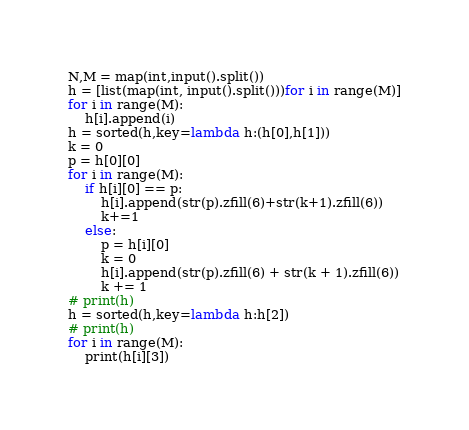Convert code to text. <code><loc_0><loc_0><loc_500><loc_500><_Python_>N,M = map(int,input().split())
h = [list(map(int, input().split()))for i in range(M)]
for i in range(M):
    h[i].append(i)
h = sorted(h,key=lambda h:(h[0],h[1]))
k = 0
p = h[0][0]
for i in range(M):
    if h[i][0] == p:
        h[i].append(str(p).zfill(6)+str(k+1).zfill(6))
        k+=1
    else:
        p = h[i][0]
        k = 0
        h[i].append(str(p).zfill(6) + str(k + 1).zfill(6))
        k += 1
# print(h)
h = sorted(h,key=lambda h:h[2])
# print(h)
for i in range(M):
    print(h[i][3])</code> 